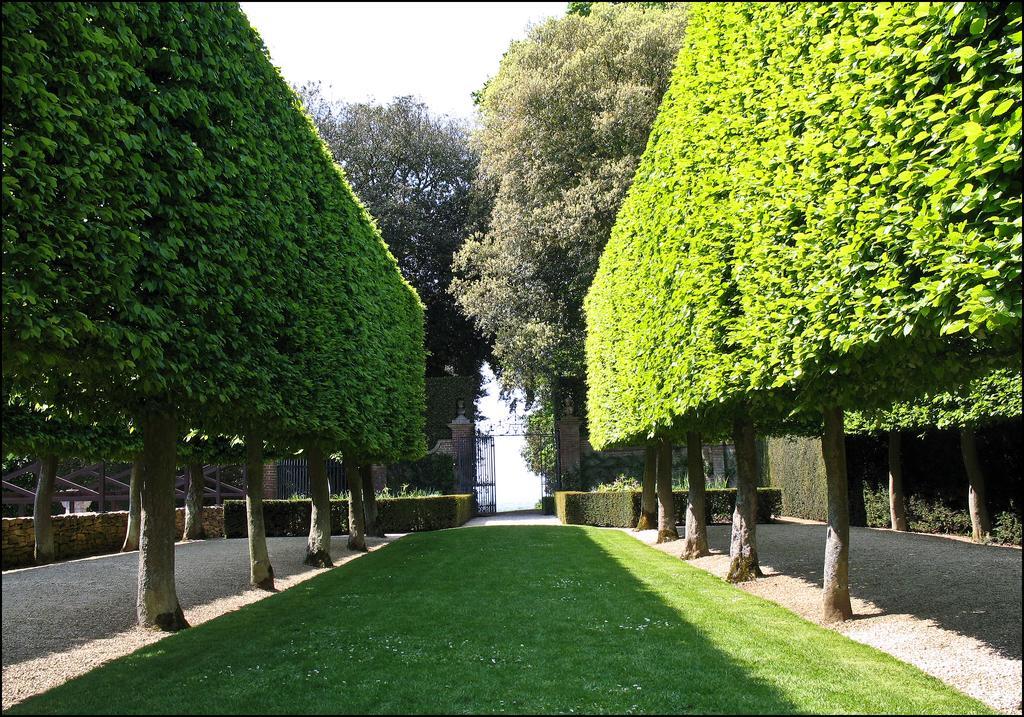In one or two sentences, can you explain what this image depicts? In the image there is a garden in the middle with trees on either side of it, in the back there is a gate with plants on either side of it and above its sky. 